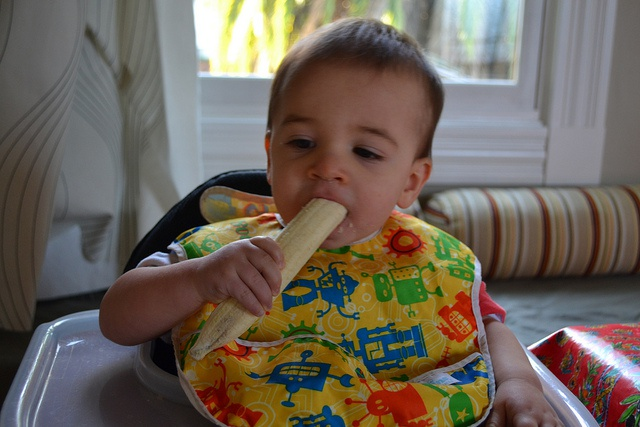Describe the objects in this image and their specific colors. I can see people in black, maroon, olive, and gray tones, bed in black, gray, maroon, and darkgray tones, and banana in black and gray tones in this image. 